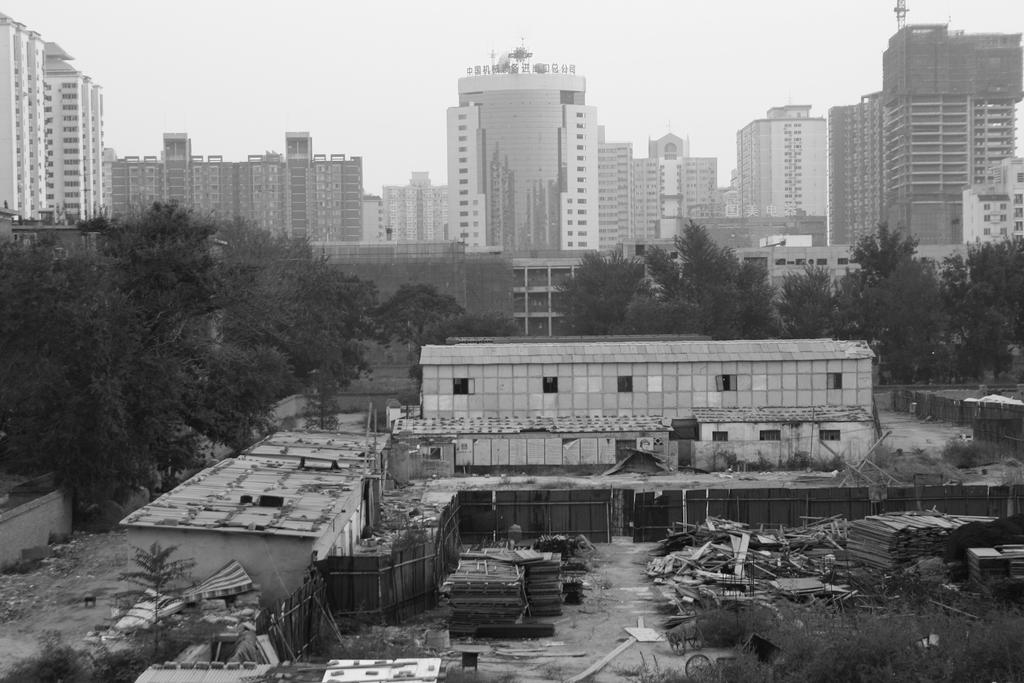What type of natural elements can be seen in the image? There are trees in the image. What type of man-made structures can be seen in the background of the image? There are buildings in the background of the image. What part of the natural environment is visible in the image? The sky is visible in the background of the image. How many queens are present in the image? There are no queens present in the image. What is the size of the cellar in the image? There is no cellar present in the image. 